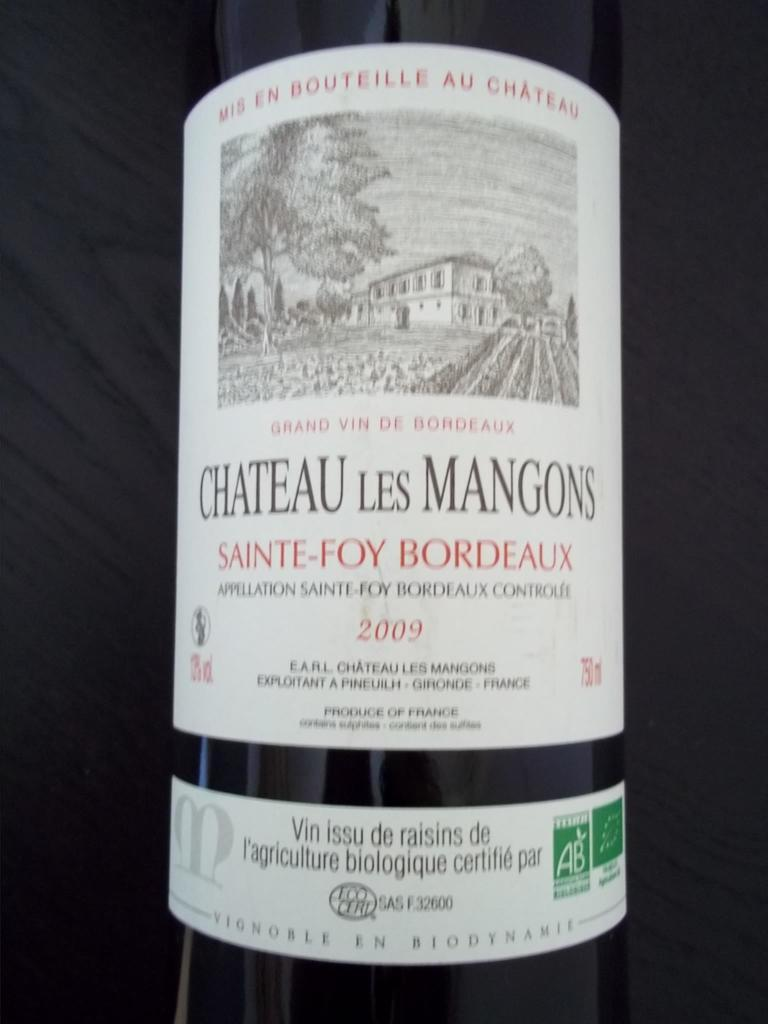What object is present in the image? There is a bottle in the image. What can be seen on the bottle? The content written on the bottle is visible and zoomed in. Where is the clam located in the image? There is no clam present in the image. What type of house is depicted on the bottle? The image does not show a house; it only shows the content written on the bottle. 